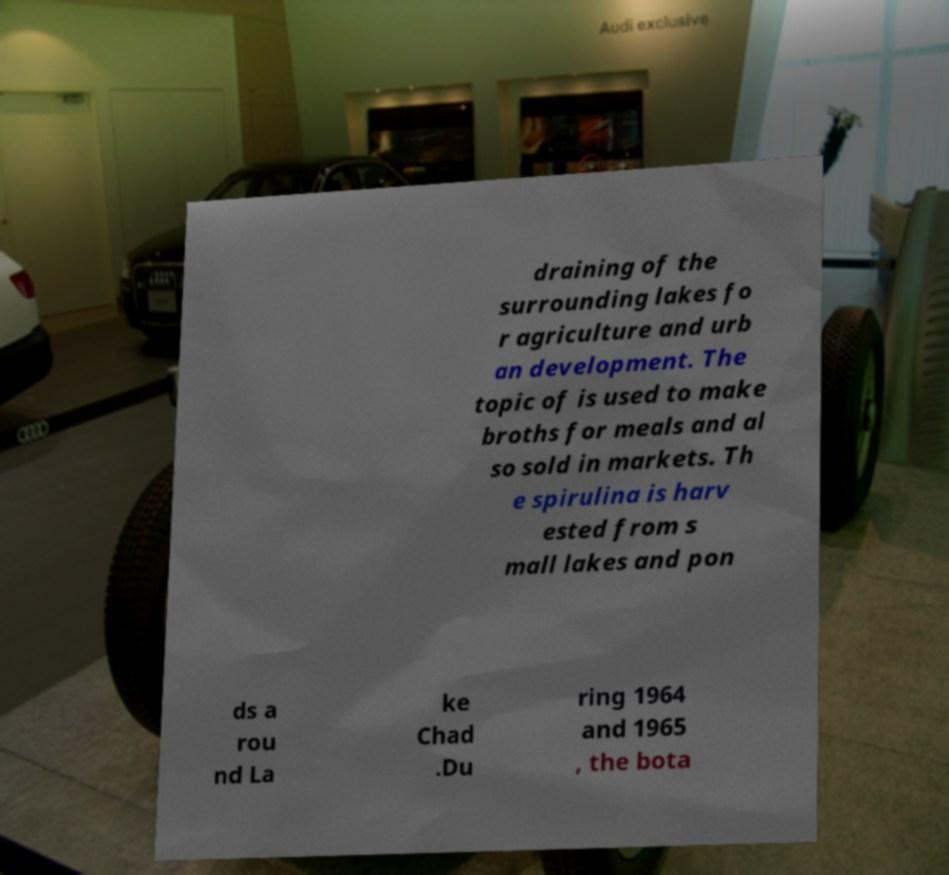Could you assist in decoding the text presented in this image and type it out clearly? draining of the surrounding lakes fo r agriculture and urb an development. The topic of is used to make broths for meals and al so sold in markets. Th e spirulina is harv ested from s mall lakes and pon ds a rou nd La ke Chad .Du ring 1964 and 1965 , the bota 